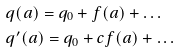<formula> <loc_0><loc_0><loc_500><loc_500>& q ( a ) = q _ { 0 } + f ( a ) + \dots \\ & q ^ { \prime } ( a ) = q _ { 0 } + c f ( a ) + \dots</formula> 